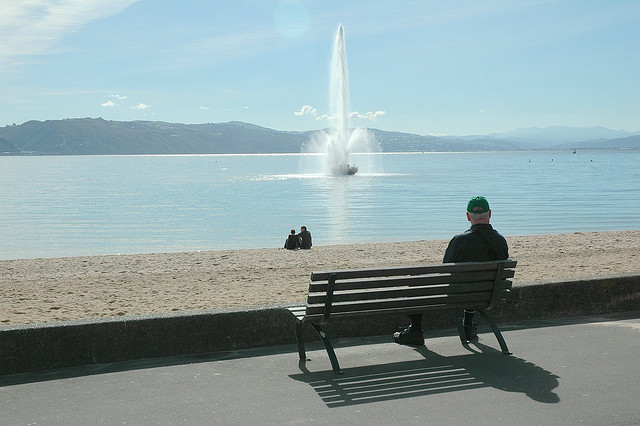<image>What are the striped containers used for? The striped containers are not visible in the image. They could potentially be used for holding items or sitting. What are the striped containers used for? I don't know what the striped containers are used for. It can be for holding, sitting or garbage. 